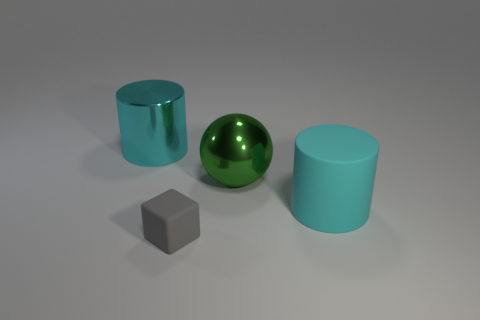Can you describe the material of the objects closest to the green sphere? Certainly, there are two cylinders close to the green sphere. The one to the left appears to have a metallic surface, similar to the green sphere, while the one to the right seems to have a matte finish, possibly resembling a rubber material. 